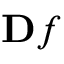Convert formula to latex. <formula><loc_0><loc_0><loc_500><loc_500>\mathbf f</formula> 